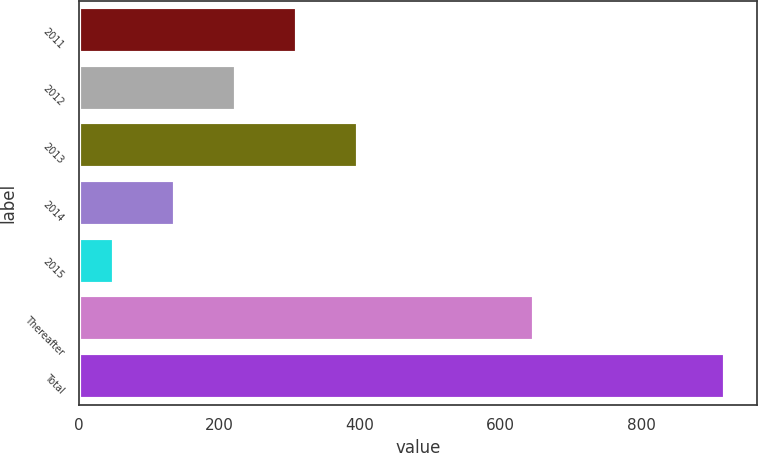Convert chart to OTSL. <chart><loc_0><loc_0><loc_500><loc_500><bar_chart><fcel>2011<fcel>2012<fcel>2013<fcel>2014<fcel>2015<fcel>Thereafter<fcel>Total<nl><fcel>310.7<fcel>223.8<fcel>397.6<fcel>136.9<fcel>50<fcel>648<fcel>919<nl></chart> 